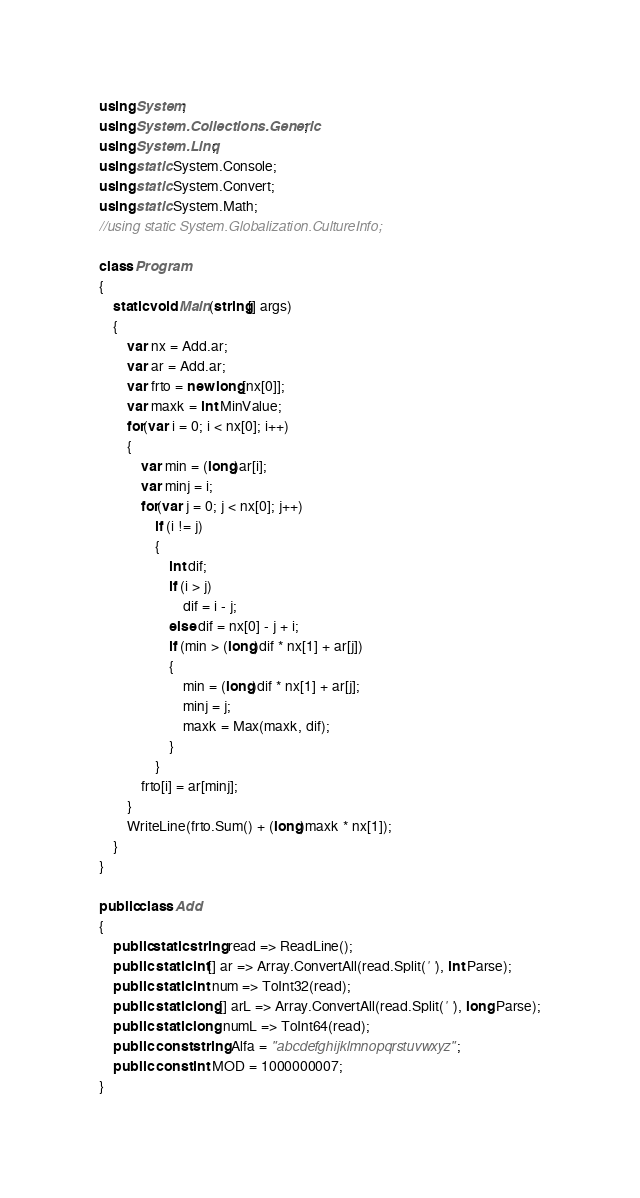<code> <loc_0><loc_0><loc_500><loc_500><_C#_>using System;
using System.Collections.Generic;
using System.Linq;
using static System.Console;
using static System.Convert;
using static System.Math;
//using static System.Globalization.CultureInfo;

class Program
{
    static void Main(string[] args)
    {
        var nx = Add.ar;
        var ar = Add.ar;
        var frto = new long[nx[0]];
        var maxk = int.MinValue;
        for(var i = 0; i < nx[0]; i++)
        {
            var min = (long)ar[i];
            var minj = i;
            for(var j = 0; j < nx[0]; j++)
                if (i != j)
                {
                    int dif;
                    if (i > j)
                        dif = i - j;
                    else dif = nx[0] - j + i;
                    if (min > (long)dif * nx[1] + ar[j])
                    {
                        min = (long)dif * nx[1] + ar[j];
                        minj = j;
                        maxk = Max(maxk, dif);
                    }
                }
            frto[i] = ar[minj];
        }
        WriteLine(frto.Sum() + (long)maxk * nx[1]);
    }
}

public class Add
{
    public static string read => ReadLine();
    public  static int[] ar => Array.ConvertAll(read.Split(' '), int.Parse);
    public  static int num => ToInt32(read);
    public  static long[] arL => Array.ConvertAll(read.Split(' '), long.Parse);
    public  static long numL => ToInt64(read);
    public  const string Alfa = "abcdefghijklmnopqrstuvwxyz";
    public  const int MOD = 1000000007;
}
</code> 